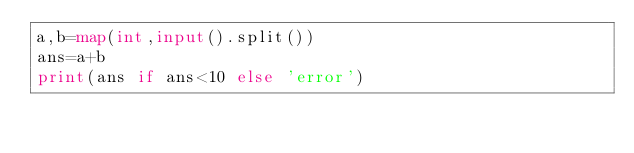<code> <loc_0><loc_0><loc_500><loc_500><_Python_>a,b=map(int,input().split())
ans=a+b
print(ans if ans<10 else 'error')</code> 